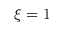<formula> <loc_0><loc_0><loc_500><loc_500>\xi = 1</formula> 